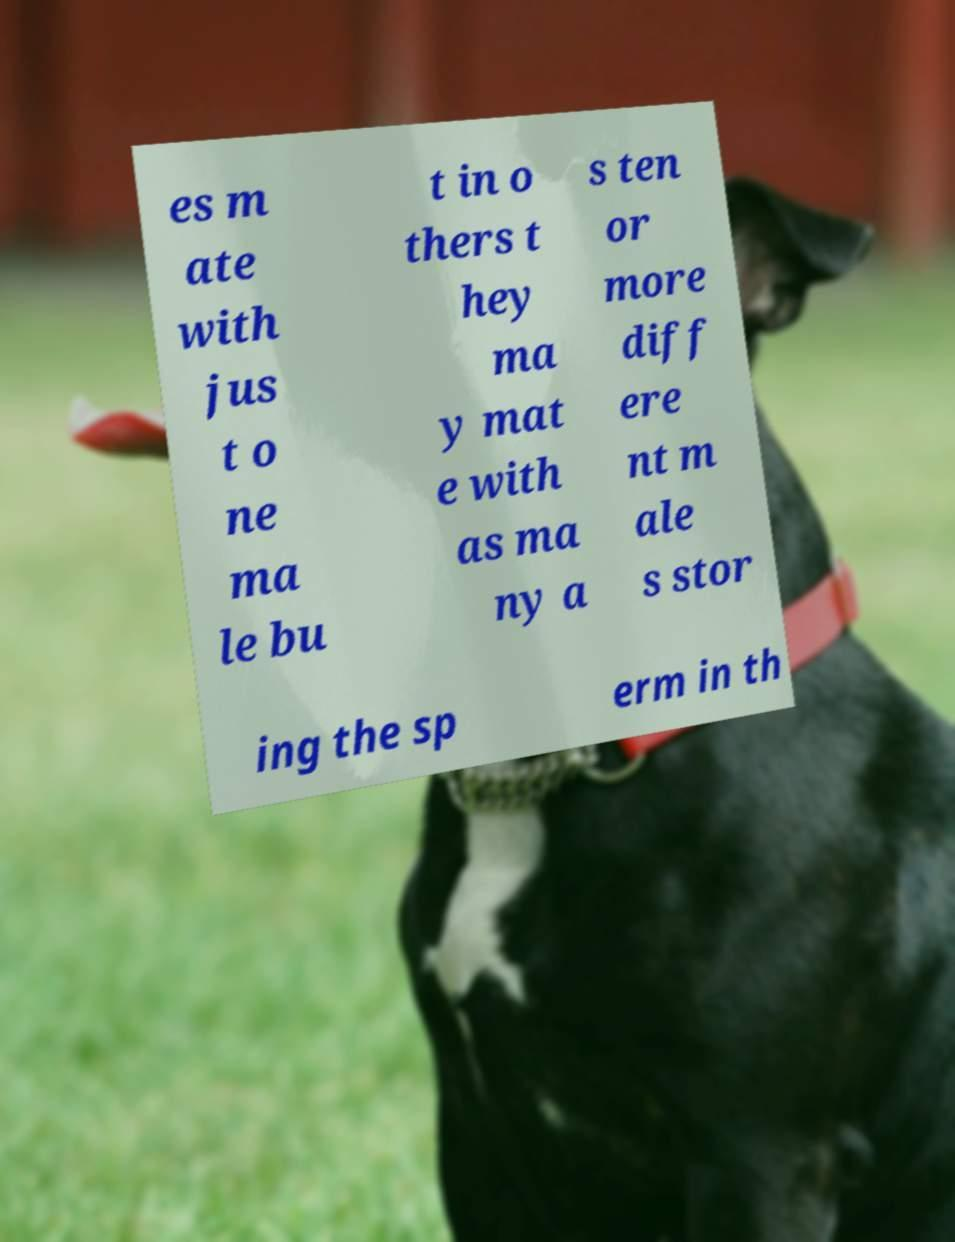Could you assist in decoding the text presented in this image and type it out clearly? es m ate with jus t o ne ma le bu t in o thers t hey ma y mat e with as ma ny a s ten or more diff ere nt m ale s stor ing the sp erm in th 